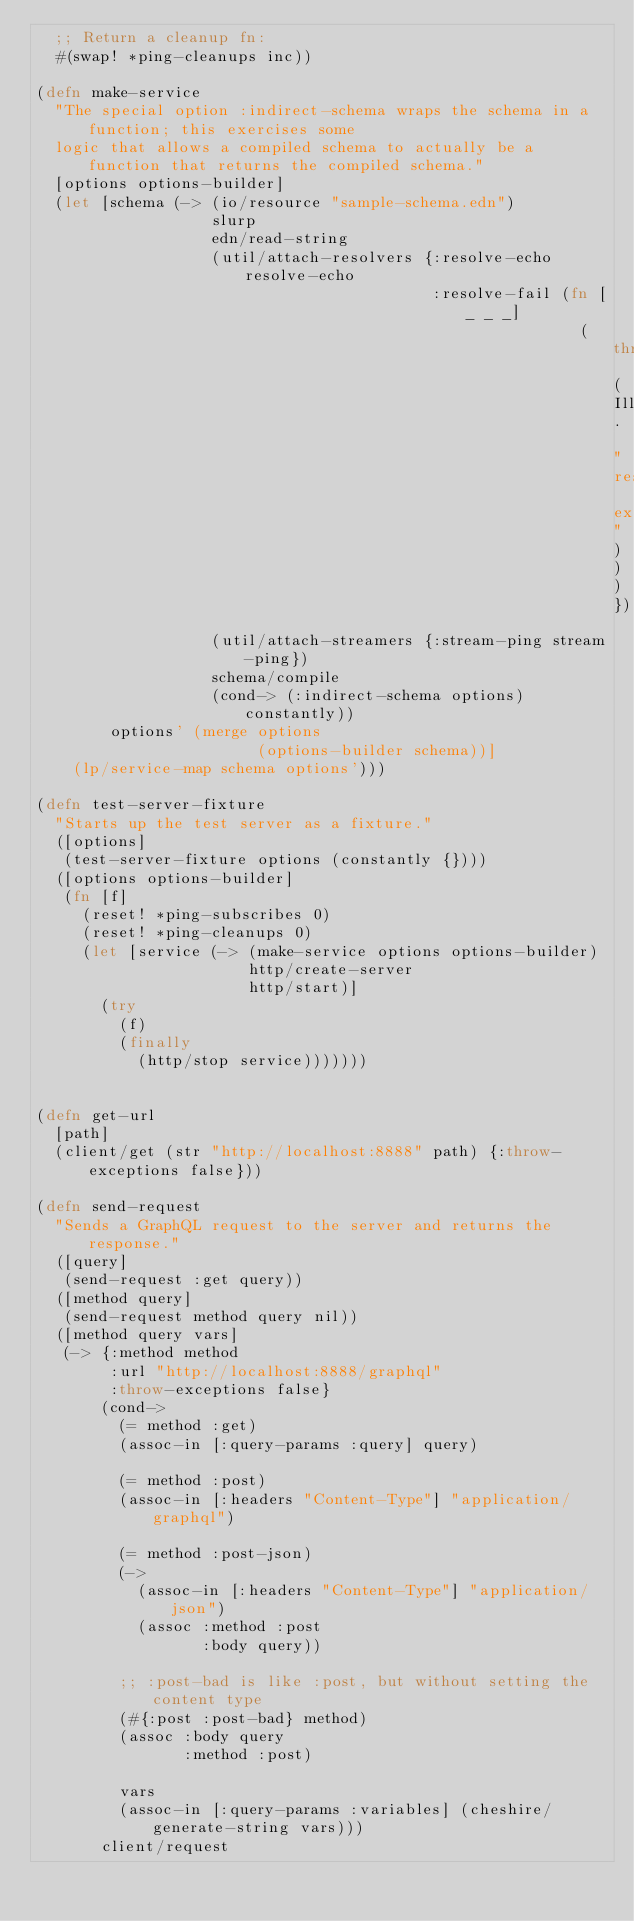Convert code to text. <code><loc_0><loc_0><loc_500><loc_500><_Clojure_>  ;; Return a cleanup fn:
  #(swap! *ping-cleanups inc))

(defn make-service
  "The special option :indirect-schema wraps the schema in a function; this exercises some
  logic that allows a compiled schema to actually be a function that returns the compiled schema."
  [options options-builder]
  (let [schema (-> (io/resource "sample-schema.edn")
                   slurp
                   edn/read-string
                   (util/attach-resolvers {:resolve-echo resolve-echo
                                           :resolve-fail (fn [_ _ _]
                                                           (throw (IllegalStateException. "resolver exception")))})
                   (util/attach-streamers {:stream-ping stream-ping})
                   schema/compile
                   (cond-> (:indirect-schema options) constantly))
        options' (merge options
                        (options-builder schema))]
    (lp/service-map schema options')))

(defn test-server-fixture
  "Starts up the test server as a fixture."
  ([options]
   (test-server-fixture options (constantly {})))
  ([options options-builder]
   (fn [f]
     (reset! *ping-subscribes 0)
     (reset! *ping-cleanups 0)
     (let [service (-> (make-service options options-builder)
                       http/create-server
                       http/start)]
       (try
         (f)
         (finally
           (http/stop service)))))))


(defn get-url
  [path]
  (client/get (str "http://localhost:8888" path) {:throw-exceptions false}))

(defn send-request
  "Sends a GraphQL request to the server and returns the response."
  ([query]
   (send-request :get query))
  ([method query]
   (send-request method query nil))
  ([method query vars]
   (-> {:method method
        :url "http://localhost:8888/graphql"
        :throw-exceptions false}
       (cond->
         (= method :get)
         (assoc-in [:query-params :query] query)

         (= method :post)
         (assoc-in [:headers "Content-Type"] "application/graphql")

         (= method :post-json)
         (->
           (assoc-in [:headers "Content-Type"] "application/json")
           (assoc :method :post
                  :body query))

         ;; :post-bad is like :post, but without setting the content type
         (#{:post :post-bad} method)
         (assoc :body query
                :method :post)

         vars
         (assoc-in [:query-params :variables] (cheshire/generate-string vars)))
       client/request</code> 